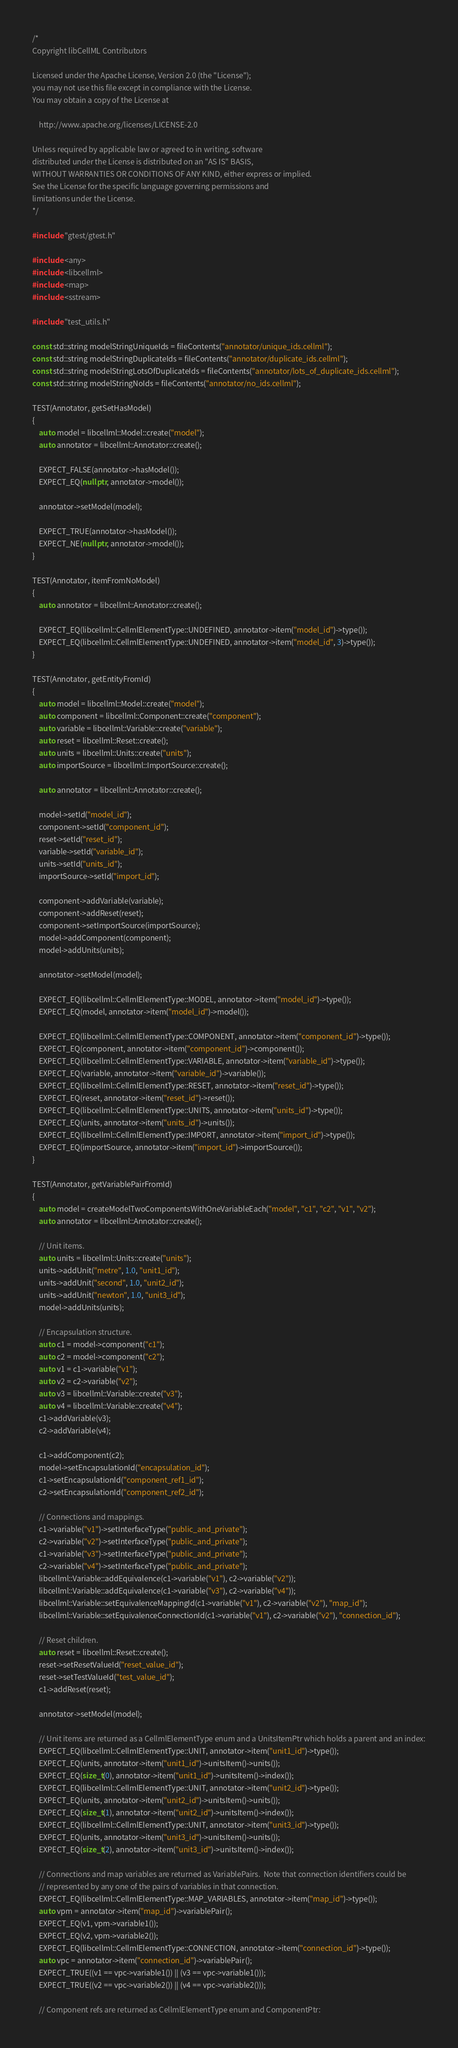<code> <loc_0><loc_0><loc_500><loc_500><_C++_>/*
Copyright libCellML Contributors

Licensed under the Apache License, Version 2.0 (the "License");
you may not use this file except in compliance with the License.
You may obtain a copy of the License at

    http://www.apache.org/licenses/LICENSE-2.0

Unless required by applicable law or agreed to in writing, software
distributed under the License is distributed on an "AS IS" BASIS,
WITHOUT WARRANTIES OR CONDITIONS OF ANY KIND, either express or implied.
See the License for the specific language governing permissions and
limitations under the License.
*/

#include "gtest/gtest.h"

#include <any>
#include <libcellml>
#include <map>
#include <sstream>

#include "test_utils.h"

const std::string modelStringUniqueIds = fileContents("annotator/unique_ids.cellml");
const std::string modelStringDuplicateIds = fileContents("annotator/duplicate_ids.cellml");
const std::string modelStringLotsOfDuplicateIds = fileContents("annotator/lots_of_duplicate_ids.cellml");
const std::string modelStringNoIds = fileContents("annotator/no_ids.cellml");

TEST(Annotator, getSetHasModel)
{
    auto model = libcellml::Model::create("model");
    auto annotator = libcellml::Annotator::create();

    EXPECT_FALSE(annotator->hasModel());
    EXPECT_EQ(nullptr, annotator->model());

    annotator->setModel(model);

    EXPECT_TRUE(annotator->hasModel());
    EXPECT_NE(nullptr, annotator->model());
}

TEST(Annotator, itemFromNoModel)
{
    auto annotator = libcellml::Annotator::create();

    EXPECT_EQ(libcellml::CellmlElementType::UNDEFINED, annotator->item("model_id")->type());
    EXPECT_EQ(libcellml::CellmlElementType::UNDEFINED, annotator->item("model_id", 3)->type());
}

TEST(Annotator, getEntityFromId)
{
    auto model = libcellml::Model::create("model");
    auto component = libcellml::Component::create("component");
    auto variable = libcellml::Variable::create("variable");
    auto reset = libcellml::Reset::create();
    auto units = libcellml::Units::create("units");
    auto importSource = libcellml::ImportSource::create();

    auto annotator = libcellml::Annotator::create();

    model->setId("model_id");
    component->setId("component_id");
    reset->setId("reset_id");
    variable->setId("variable_id");
    units->setId("units_id");
    importSource->setId("import_id");

    component->addVariable(variable);
    component->addReset(reset);
    component->setImportSource(importSource);
    model->addComponent(component);
    model->addUnits(units);

    annotator->setModel(model);

    EXPECT_EQ(libcellml::CellmlElementType::MODEL, annotator->item("model_id")->type());
    EXPECT_EQ(model, annotator->item("model_id")->model());

    EXPECT_EQ(libcellml::CellmlElementType::COMPONENT, annotator->item("component_id")->type());
    EXPECT_EQ(component, annotator->item("component_id")->component());
    EXPECT_EQ(libcellml::CellmlElementType::VARIABLE, annotator->item("variable_id")->type());
    EXPECT_EQ(variable, annotator->item("variable_id")->variable());
    EXPECT_EQ(libcellml::CellmlElementType::RESET, annotator->item("reset_id")->type());
    EXPECT_EQ(reset, annotator->item("reset_id")->reset());
    EXPECT_EQ(libcellml::CellmlElementType::UNITS, annotator->item("units_id")->type());
    EXPECT_EQ(units, annotator->item("units_id")->units());
    EXPECT_EQ(libcellml::CellmlElementType::IMPORT, annotator->item("import_id")->type());
    EXPECT_EQ(importSource, annotator->item("import_id")->importSource());
}

TEST(Annotator, getVariablePairFromId)
{
    auto model = createModelTwoComponentsWithOneVariableEach("model", "c1", "c2", "v1", "v2");
    auto annotator = libcellml::Annotator::create();

    // Unit items.
    auto units = libcellml::Units::create("units");
    units->addUnit("metre", 1.0, "unit1_id");
    units->addUnit("second", 1.0, "unit2_id");
    units->addUnit("newton", 1.0, "unit3_id");
    model->addUnits(units);

    // Encapsulation structure.
    auto c1 = model->component("c1");
    auto c2 = model->component("c2");
    auto v1 = c1->variable("v1");
    auto v2 = c2->variable("v2");
    auto v3 = libcellml::Variable::create("v3");
    auto v4 = libcellml::Variable::create("v4");
    c1->addVariable(v3);
    c2->addVariable(v4);

    c1->addComponent(c2);
    model->setEncapsulationId("encapsulation_id");
    c1->setEncapsulationId("component_ref1_id");
    c2->setEncapsulationId("component_ref2_id");

    // Connections and mappings.
    c1->variable("v1")->setInterfaceType("public_and_private");
    c2->variable("v2")->setInterfaceType("public_and_private");
    c1->variable("v3")->setInterfaceType("public_and_private");
    c2->variable("v4")->setInterfaceType("public_and_private");
    libcellml::Variable::addEquivalence(c1->variable("v1"), c2->variable("v2"));
    libcellml::Variable::addEquivalence(c1->variable("v3"), c2->variable("v4"));
    libcellml::Variable::setEquivalenceMappingId(c1->variable("v1"), c2->variable("v2"), "map_id");
    libcellml::Variable::setEquivalenceConnectionId(c1->variable("v1"), c2->variable("v2"), "connection_id");

    // Reset children.
    auto reset = libcellml::Reset::create();
    reset->setResetValueId("reset_value_id");
    reset->setTestValueId("test_value_id");
    c1->addReset(reset);

    annotator->setModel(model);

    // Unit items are returned as a CellmlElementType enum and a UnitsItemPtr which holds a parent and an index:
    EXPECT_EQ(libcellml::CellmlElementType::UNIT, annotator->item("unit1_id")->type());
    EXPECT_EQ(units, annotator->item("unit1_id")->unitsItem()->units());
    EXPECT_EQ(size_t(0), annotator->item("unit1_id")->unitsItem()->index());
    EXPECT_EQ(libcellml::CellmlElementType::UNIT, annotator->item("unit2_id")->type());
    EXPECT_EQ(units, annotator->item("unit2_id")->unitsItem()->units());
    EXPECT_EQ(size_t(1), annotator->item("unit2_id")->unitsItem()->index());
    EXPECT_EQ(libcellml::CellmlElementType::UNIT, annotator->item("unit3_id")->type());
    EXPECT_EQ(units, annotator->item("unit3_id")->unitsItem()->units());
    EXPECT_EQ(size_t(2), annotator->item("unit3_id")->unitsItem()->index());

    // Connections and map variables are returned as VariablePairs.  Note that connection identifiers could be
    // represented by any one of the pairs of variables in that connection.
    EXPECT_EQ(libcellml::CellmlElementType::MAP_VARIABLES, annotator->item("map_id")->type());
    auto vpm = annotator->item("map_id")->variablePair();
    EXPECT_EQ(v1, vpm->variable1());
    EXPECT_EQ(v2, vpm->variable2());
    EXPECT_EQ(libcellml::CellmlElementType::CONNECTION, annotator->item("connection_id")->type());
    auto vpc = annotator->item("connection_id")->variablePair();
    EXPECT_TRUE((v1 == vpc->variable1()) || (v3 == vpc->variable1()));
    EXPECT_TRUE((v2 == vpc->variable2()) || (v4 == vpc->variable2()));

    // Component refs are returned as CellmlElementType enum and ComponentPtr:</code> 